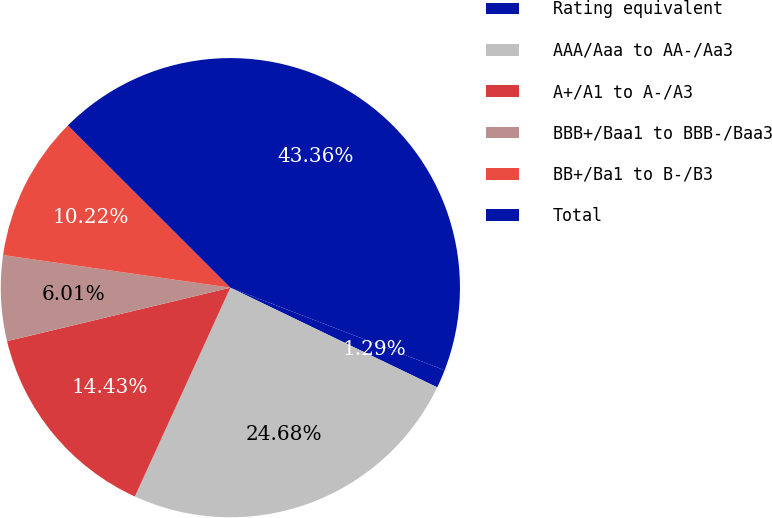<chart> <loc_0><loc_0><loc_500><loc_500><pie_chart><fcel>Rating equivalent<fcel>AAA/Aaa to AA-/Aa3<fcel>A+/A1 to A-/A3<fcel>BBB+/Baa1 to BBB-/Baa3<fcel>BB+/Ba1 to B-/B3<fcel>Total<nl><fcel>1.29%<fcel>24.68%<fcel>14.43%<fcel>6.01%<fcel>10.22%<fcel>43.36%<nl></chart> 